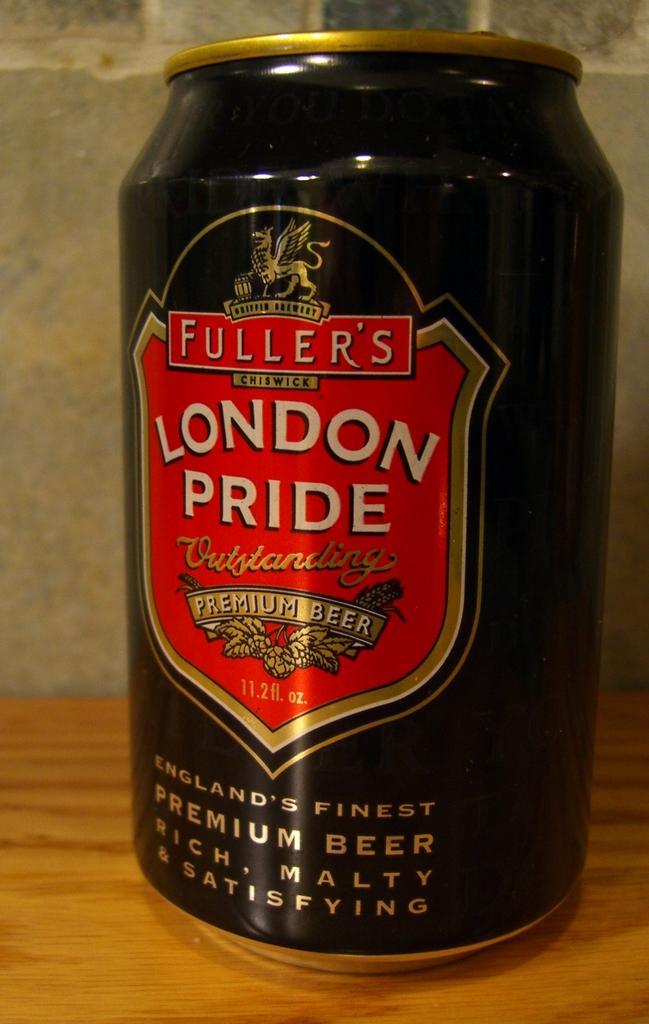What is the color of the tin in the image? The tin in the image is black. What can be found on the surface of the tin? Something is written on the tin. What is the color of the surface on which the tin is placed? The tin is on a brown surface. What type of hope can be seen growing on the sidewalk in the image? There is no sidewalk or hope present in the image; it only features a black tin on a brown surface. 